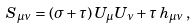Convert formula to latex. <formula><loc_0><loc_0><loc_500><loc_500>S _ { \mu \nu } = ( \sigma + \tau ) \, U _ { \mu } U _ { \nu } + \tau \, h _ { \mu \nu } \, ,</formula> 